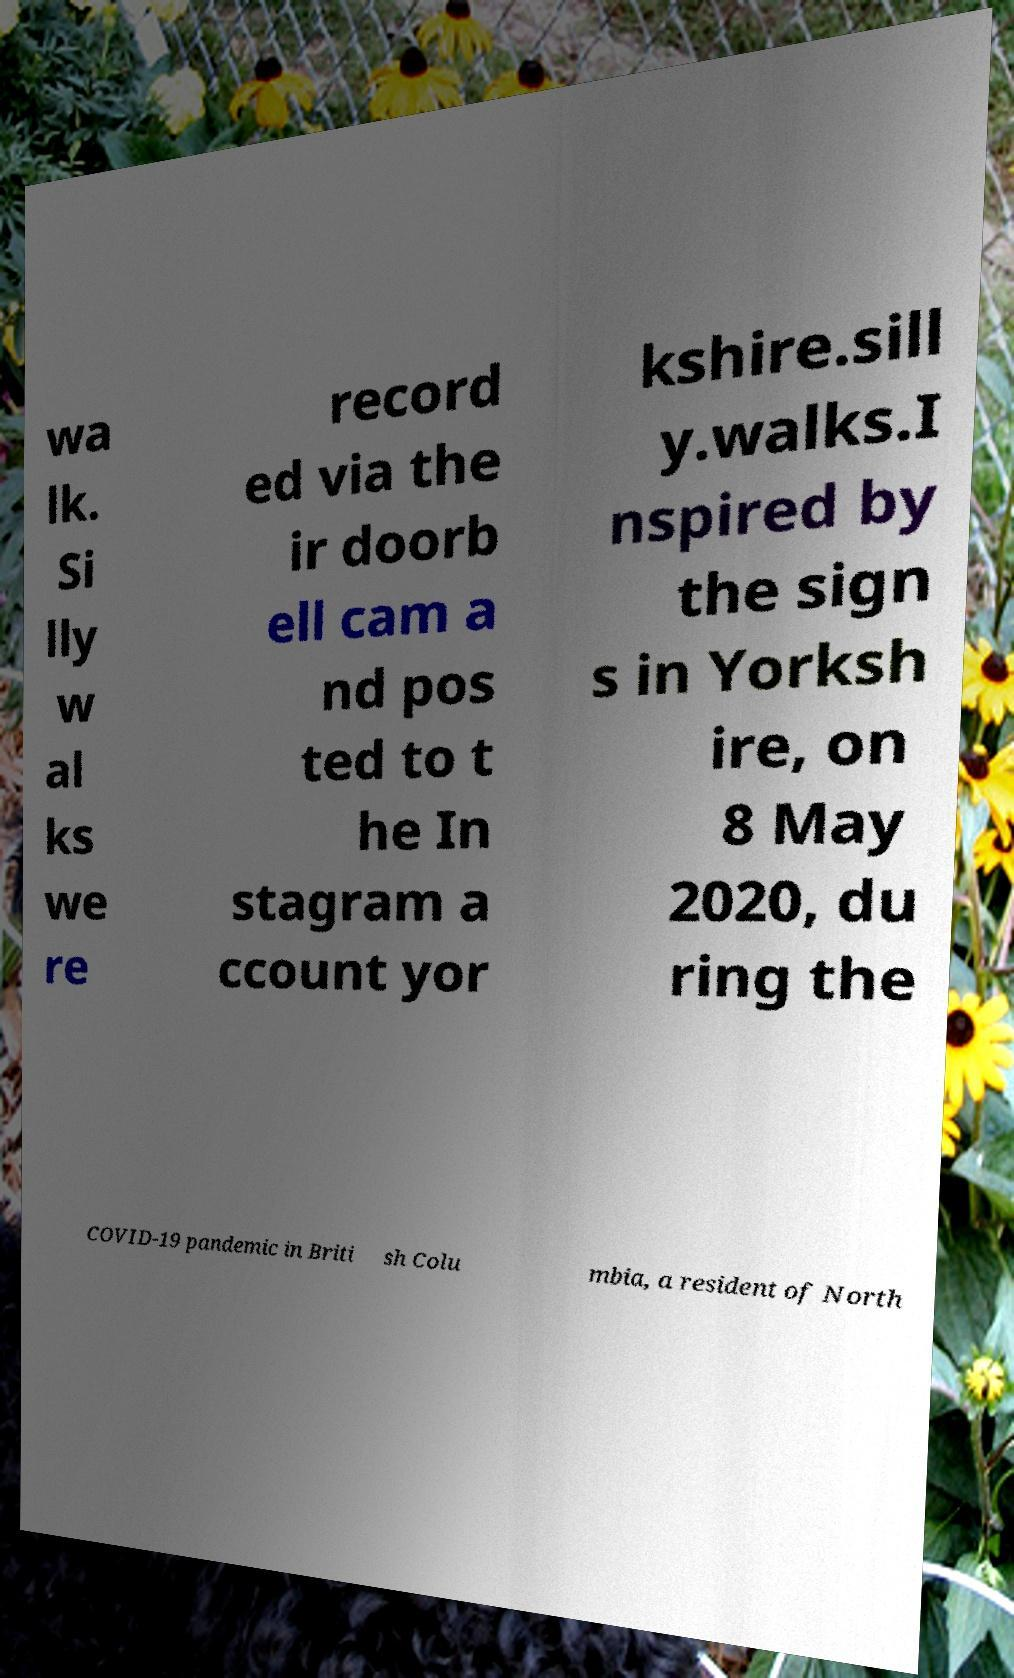For documentation purposes, I need the text within this image transcribed. Could you provide that? wa lk. Si lly w al ks we re record ed via the ir doorb ell cam a nd pos ted to t he In stagram a ccount yor kshire.sill y.walks.I nspired by the sign s in Yorksh ire, on 8 May 2020, du ring the COVID-19 pandemic in Briti sh Colu mbia, a resident of North 